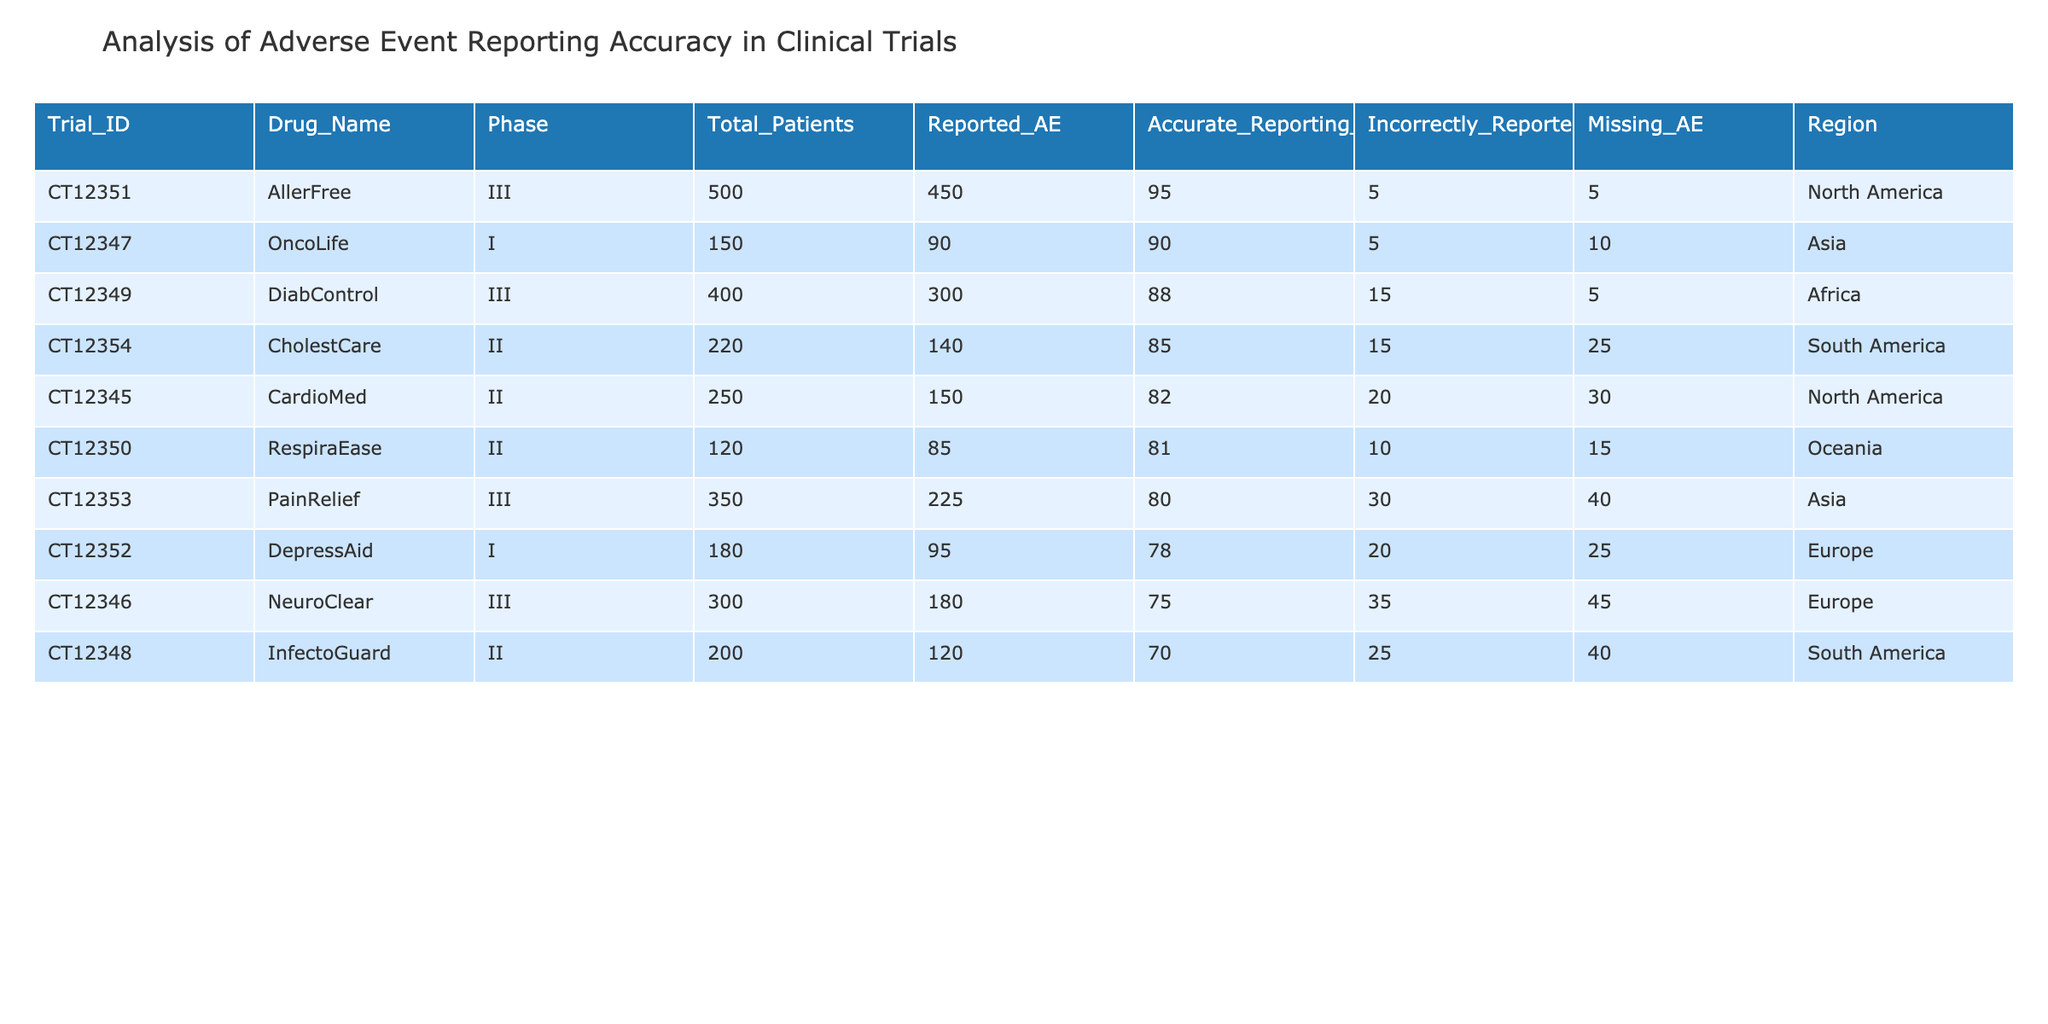What is the accurate reporting percentage for the drug NeuroClear? The table shows that NeuroClear has an accurate reporting percentage of 75.0%.
Answer: 75.0% Which trial has the highest number of total patients? By examining the Total_Patients column, DiabControl has the highest count with 400 patients.
Answer: 400 Is the reporting of adverse events for the drug AllerFree considered accurate or not? The accurate reporting percentage for AllerFree is 95.0%, which indicates that it is considered accurate.
Answer: Yes What is the difference in accurate reporting percentage between the drugs CardioMed and InfectoGuard? CardioMed has an accurate reporting percentage of 82.0%, while InfectoGuard has 70.0%. The difference is 82.0% - 70.0% = 12.0%.
Answer: 12.0% Which region has the lowest number of reported adverse events? By checking the Reported_AE column, InfectoGuard from the South America region has the lowest reported adverse events at 120.
Answer: 120 What is the average accurate reporting percentage across all trials? To find the average, sum all the accurate reporting percentages: (82.0 + 75.0 + 90.0 + 70.0 + 88.0 + 81.0 + 95.0 + 78.0 + 80.0 + 85.0) = 834.0. There are 10 trials, so the average is 834.0 / 10 = 83.4%.
Answer: 83.4% Are there any trials where the number of incorrectly reported adverse events exceeds 30? By reviewing the Incorrectly_Reported_AE column, North America has two trials (NeuroClear and PainRelief) where the incorrectly reported AE exceed 30.
Answer: Yes Which trial has the highest number of missing adverse events? By inspecting the Missing_AE column, InfectoGuard has the highest with 40 missing adverse events.
Answer: 40 What is the total number of adverse events reported across all trials? To get the total reported adverse events, sum the Reported_AE column: (150 + 180 + 90 + 120 + 300 + 85 + 450 + 95 + 225 + 140) = 1890.
Answer: 1890 